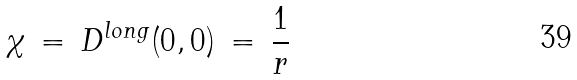<formula> <loc_0><loc_0><loc_500><loc_500>\chi \, = \, D ^ { l o n g } ( 0 , 0 ) \, = \, \frac { 1 } { r }</formula> 